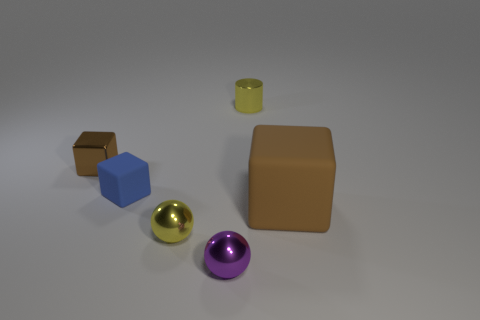Can you describe the spatial arrangement of the colorful objects in the image? Certainly, the image features a collection of geometric shapes with various colors and materials. Center stage is a sizable brown rubber block that commands your attention. Surrounding it are smaller objects including a tiny yellow cylinder to its left rear, a blue cube, and two spheres—a golden one and a purple one—lying in the foreground, all resting on a nondescript surface that fades into the background.  Are any of the objects casting shadows, and what does that tell us about the lighting? Each object casts a subtle shadow towards the rear right side, indicating a light source positioned to the front left of the scene. The shadows are soft-edged, suggesting the light source is diffused, and the scene is likely illuminated by either a single light or the primary light is dominant. 